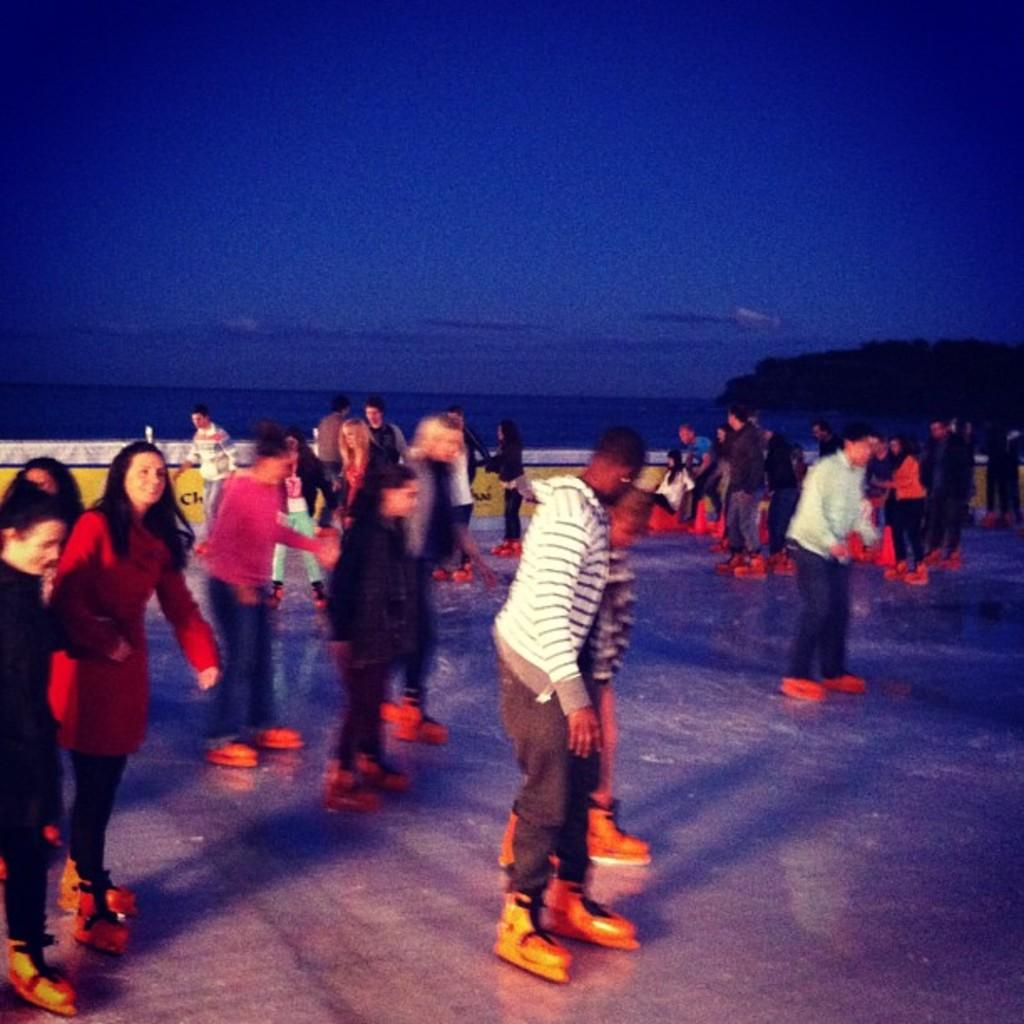What activity are the people in the image engaged in? People are skating in the image. How do the people in the image seem to be feeling? The people appear to be enjoying themselves. What can be seen in the background of the image? The sky is visible in the background of the image. Where is the baseball located in the image? There is no baseball present in the image. Can you describe the sink in the image? There is no sink present in the image. 